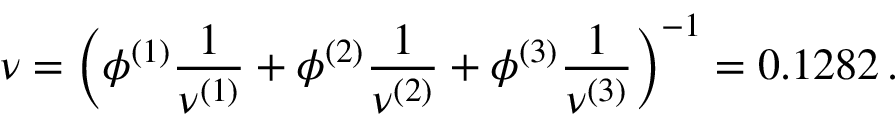<formula> <loc_0><loc_0><loc_500><loc_500>\nu = \left ( \phi ^ { ( 1 ) } \frac { 1 } { \nu ^ { ( 1 ) } } + \phi ^ { ( 2 ) } \frac { 1 } { \nu ^ { ( 2 ) } } + \phi ^ { ( 3 ) } \frac { 1 } { \nu ^ { ( 3 ) } } \right ) ^ { - 1 } = 0 . 1 2 8 2 \, .</formula> 